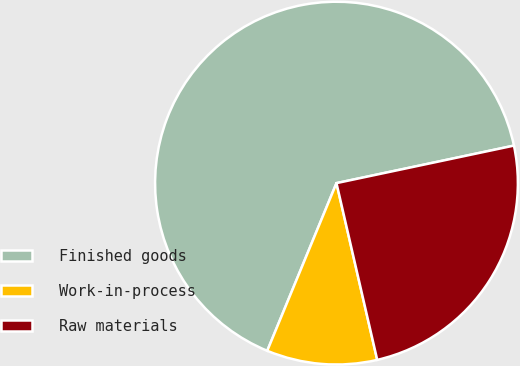<chart> <loc_0><loc_0><loc_500><loc_500><pie_chart><fcel>Finished goods<fcel>Work-in-process<fcel>Raw materials<nl><fcel>65.45%<fcel>9.84%<fcel>24.71%<nl></chart> 